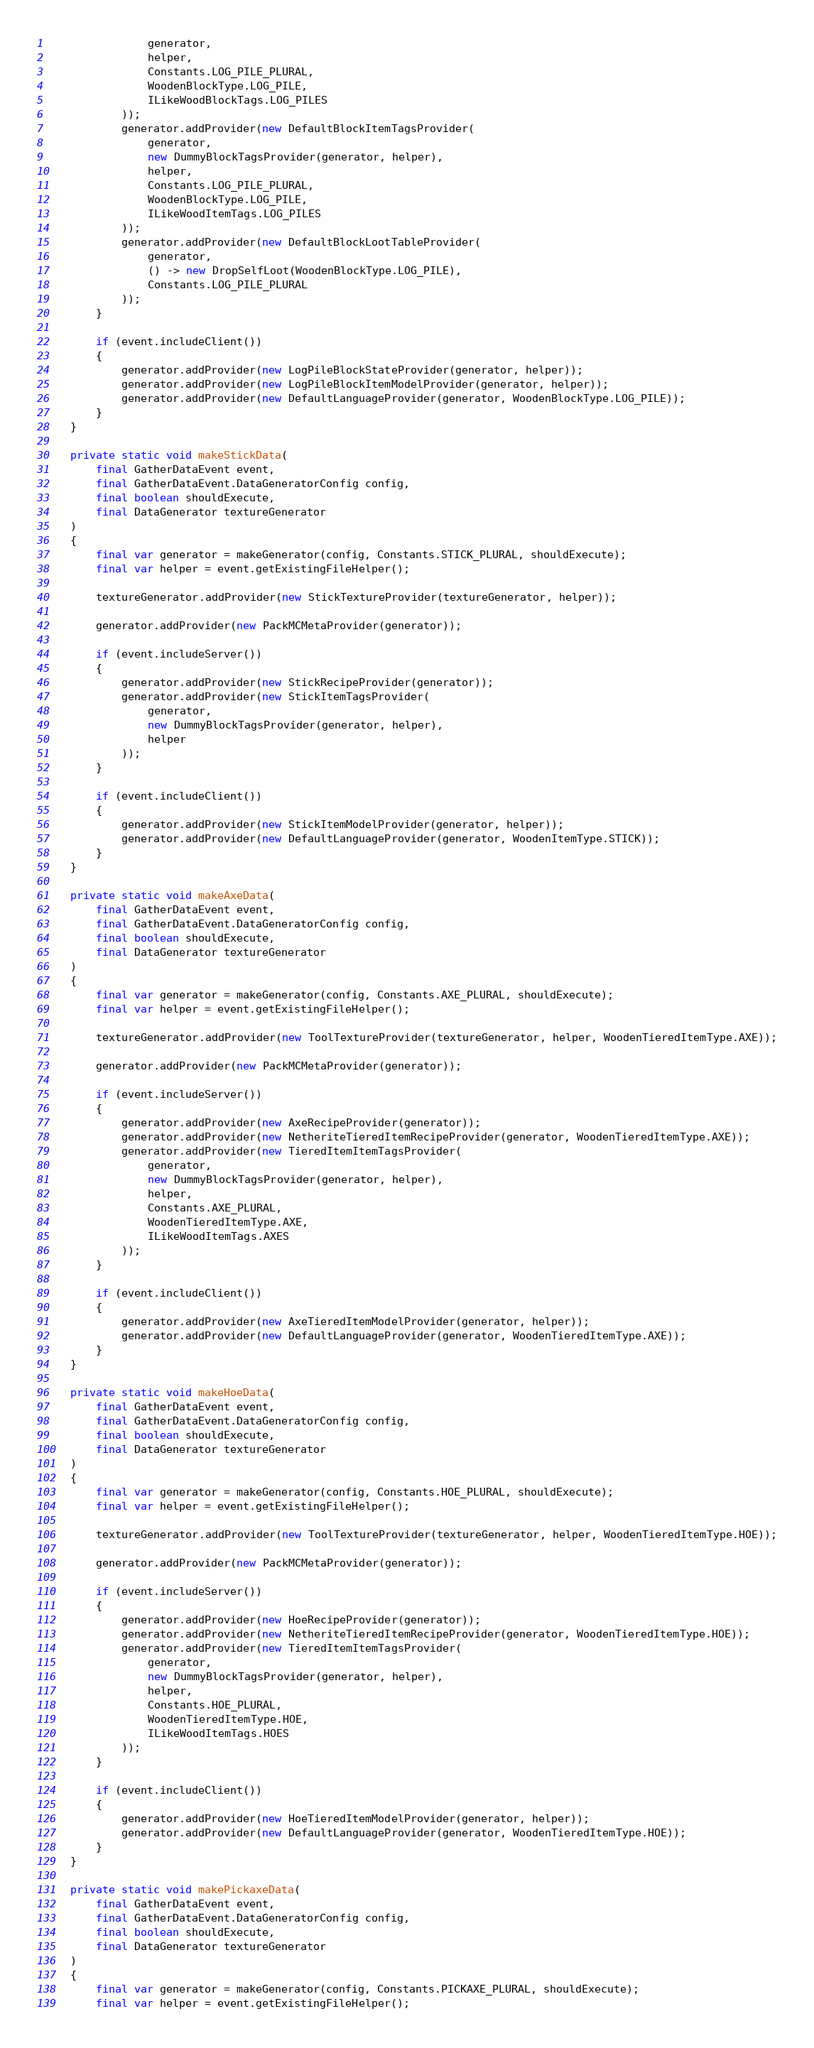Convert code to text. <code><loc_0><loc_0><loc_500><loc_500><_Java_>                generator,
                helper,
                Constants.LOG_PILE_PLURAL,
                WoodenBlockType.LOG_PILE,
                ILikeWoodBlockTags.LOG_PILES
            ));
            generator.addProvider(new DefaultBlockItemTagsProvider(
                generator,
                new DummyBlockTagsProvider(generator, helper),
                helper,
                Constants.LOG_PILE_PLURAL,
                WoodenBlockType.LOG_PILE,
                ILikeWoodItemTags.LOG_PILES
            ));
            generator.addProvider(new DefaultBlockLootTableProvider(
                generator,
                () -> new DropSelfLoot(WoodenBlockType.LOG_PILE),
                Constants.LOG_PILE_PLURAL
            ));
        }

        if (event.includeClient())
        {
            generator.addProvider(new LogPileBlockStateProvider(generator, helper));
            generator.addProvider(new LogPileBlockItemModelProvider(generator, helper));
            generator.addProvider(new DefaultLanguageProvider(generator, WoodenBlockType.LOG_PILE));
        }
    }

    private static void makeStickData(
        final GatherDataEvent event,
        final GatherDataEvent.DataGeneratorConfig config,
        final boolean shouldExecute,
        final DataGenerator textureGenerator
    )
    {
        final var generator = makeGenerator(config, Constants.STICK_PLURAL, shouldExecute);
        final var helper = event.getExistingFileHelper();

        textureGenerator.addProvider(new StickTextureProvider(textureGenerator, helper));

        generator.addProvider(new PackMCMetaProvider(generator));

        if (event.includeServer())
        {
            generator.addProvider(new StickRecipeProvider(generator));
            generator.addProvider(new StickItemTagsProvider(
                generator,
                new DummyBlockTagsProvider(generator, helper),
                helper
            ));
        }

        if (event.includeClient())
        {
            generator.addProvider(new StickItemModelProvider(generator, helper));
            generator.addProvider(new DefaultLanguageProvider(generator, WoodenItemType.STICK));
        }
    }

    private static void makeAxeData(
        final GatherDataEvent event,
        final GatherDataEvent.DataGeneratorConfig config,
        final boolean shouldExecute,
        final DataGenerator textureGenerator
    )
    {
        final var generator = makeGenerator(config, Constants.AXE_PLURAL, shouldExecute);
        final var helper = event.getExistingFileHelper();

        textureGenerator.addProvider(new ToolTextureProvider(textureGenerator, helper, WoodenTieredItemType.AXE));

        generator.addProvider(new PackMCMetaProvider(generator));

        if (event.includeServer())
        {
            generator.addProvider(new AxeRecipeProvider(generator));
            generator.addProvider(new NetheriteTieredItemRecipeProvider(generator, WoodenTieredItemType.AXE));
            generator.addProvider(new TieredItemItemTagsProvider(
                generator,
                new DummyBlockTagsProvider(generator, helper),
                helper,
                Constants.AXE_PLURAL,
                WoodenTieredItemType.AXE,
                ILikeWoodItemTags.AXES
            ));
        }

        if (event.includeClient())
        {
            generator.addProvider(new AxeTieredItemModelProvider(generator, helper));
            generator.addProvider(new DefaultLanguageProvider(generator, WoodenTieredItemType.AXE));
        }
    }

    private static void makeHoeData(
        final GatherDataEvent event,
        final GatherDataEvent.DataGeneratorConfig config,
        final boolean shouldExecute,
        final DataGenerator textureGenerator
    )
    {
        final var generator = makeGenerator(config, Constants.HOE_PLURAL, shouldExecute);
        final var helper = event.getExistingFileHelper();

        textureGenerator.addProvider(new ToolTextureProvider(textureGenerator, helper, WoodenTieredItemType.HOE));

        generator.addProvider(new PackMCMetaProvider(generator));

        if (event.includeServer())
        {
            generator.addProvider(new HoeRecipeProvider(generator));
            generator.addProvider(new NetheriteTieredItemRecipeProvider(generator, WoodenTieredItemType.HOE));
            generator.addProvider(new TieredItemItemTagsProvider(
                generator,
                new DummyBlockTagsProvider(generator, helper),
                helper,
                Constants.HOE_PLURAL,
                WoodenTieredItemType.HOE,
                ILikeWoodItemTags.HOES
            ));
        }

        if (event.includeClient())
        {
            generator.addProvider(new HoeTieredItemModelProvider(generator, helper));
            generator.addProvider(new DefaultLanguageProvider(generator, WoodenTieredItemType.HOE));
        }
    }

    private static void makePickaxeData(
        final GatherDataEvent event,
        final GatherDataEvent.DataGeneratorConfig config,
        final boolean shouldExecute,
        final DataGenerator textureGenerator
    )
    {
        final var generator = makeGenerator(config, Constants.PICKAXE_PLURAL, shouldExecute);
        final var helper = event.getExistingFileHelper();
</code> 